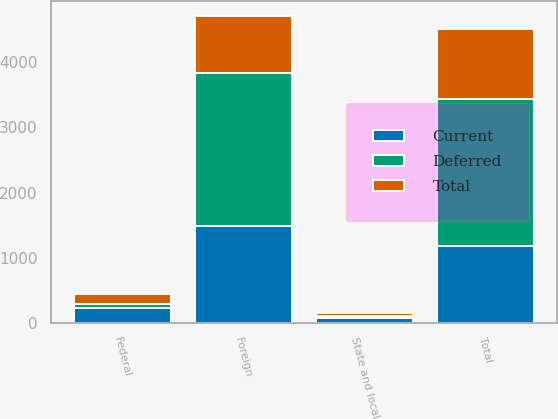<chart> <loc_0><loc_0><loc_500><loc_500><stacked_bar_chart><ecel><fcel>Federal<fcel>State and local<fcel>Foreign<fcel>Total<nl><fcel>Current<fcel>224<fcel>75<fcel>1484<fcel>1185<nl><fcel>Total<fcel>162<fcel>40<fcel>870<fcel>1072<nl><fcel>Deferred<fcel>62<fcel>35<fcel>2354<fcel>2257<nl></chart> 